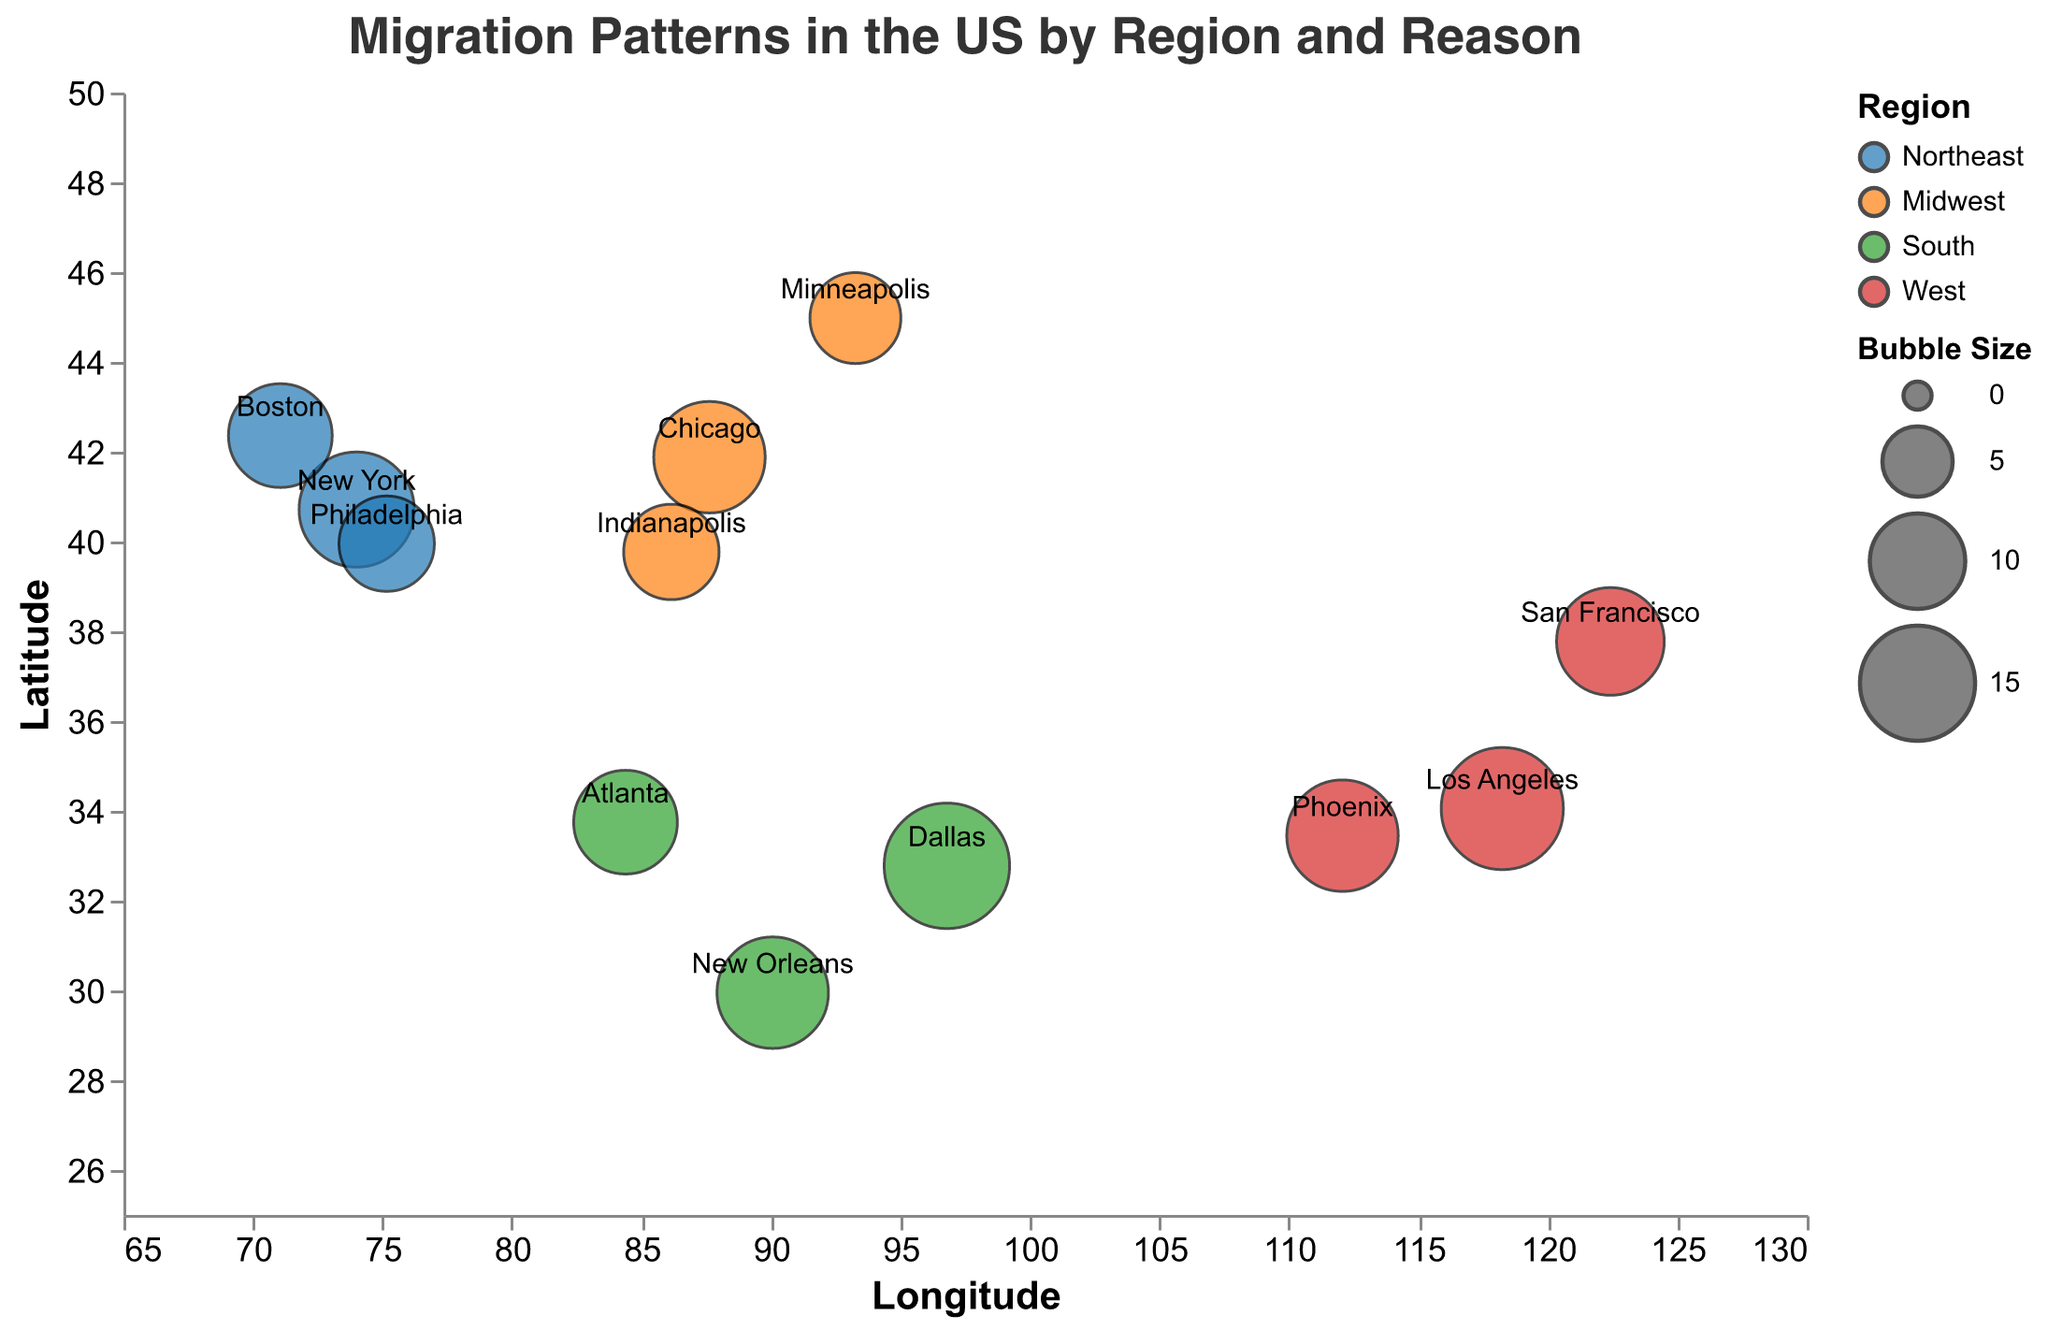What is the title of the figure? The title is indicated at the top of the figure, and it states the overall theme of the chart.
Answer: Migration Patterns in the US by Region and Reason Which region has the largest bubble for Job Opportunity, and what city does it correspond to? The color and size of bubbles indicate different regions and counts, respectively. The South region has the largest bubble for Job Opportunity which corresponds to Dallas.
Answer: South, Dallas What is the count of people migrating for education in the West region? Look for the bubble associated with Education in the West region, represented by a red bubble, and find the count. San Francisco represents this data point.
Answer: 60000 Which bubble represents Family Reasons in the Midwest, and what is its bubble size? Identify the bubble with the Midwest color and Family Reasons tag. The corresponding bubble for Family Reasons in the Midwest is Indianapolis, with a bubble size of 10.
Answer: Indianapolis, 10 Compare the bubble sizes for Job Opportunity in the Northeast and West regions. Which one is larger, and by how much? Find the bubbles for Job Opportunity in the Northeast and West regions and compare their sizes. New York (Northeast) has a bubble size of 15, and Los Angeles (West) has a size of 17. The bubble size for Los Angeles is larger by 2 units.
Answer: Los Angeles is larger by 2 units Which city in the Northeast has the smallest bubble and what is it representing? By referring to the bubble sizes in the Northeast region, the smallest bubble corresponds to Philadelphia, and it represents Education.
Answer: Philadelphia, Education Sum the counts of people relocating for Family Reasons across all regions. Sum the counts associated with Family Reasons in each region. 50000 (Boston) + 40000 (Indianapolis) + 75000 (New Orleans) + 70000 (Phoenix) = 235000.
Answer: 235000 What is the reasoning for the largest migration count in the South region? Identify the largest bubble in the South region and check its reasoning. The largest bubble corresponds to Job Opportunity with 160000 migrants in Dallas.
Answer: Job Opportunity Which regions have more people migrating for education: Northeast or South? Compare the counts of education-related migration for the Northeast and South regions. Northeast (Philadelphia): 35000, South (Atlanta): 45000. The South has more people migrating for education.
Answer: South How do the migration patterns for Family Reasons vary between the West and Midwest regions? Compare the count and bubble size for Family Reasons between the West and Midwest regions. Phoenix (West): 70000 with size 14, Indianapolis (Midwest): 40000 with size 10. The West has a larger count and bubble size for Family Reasons.
Answer: West, larger count and bubble size 